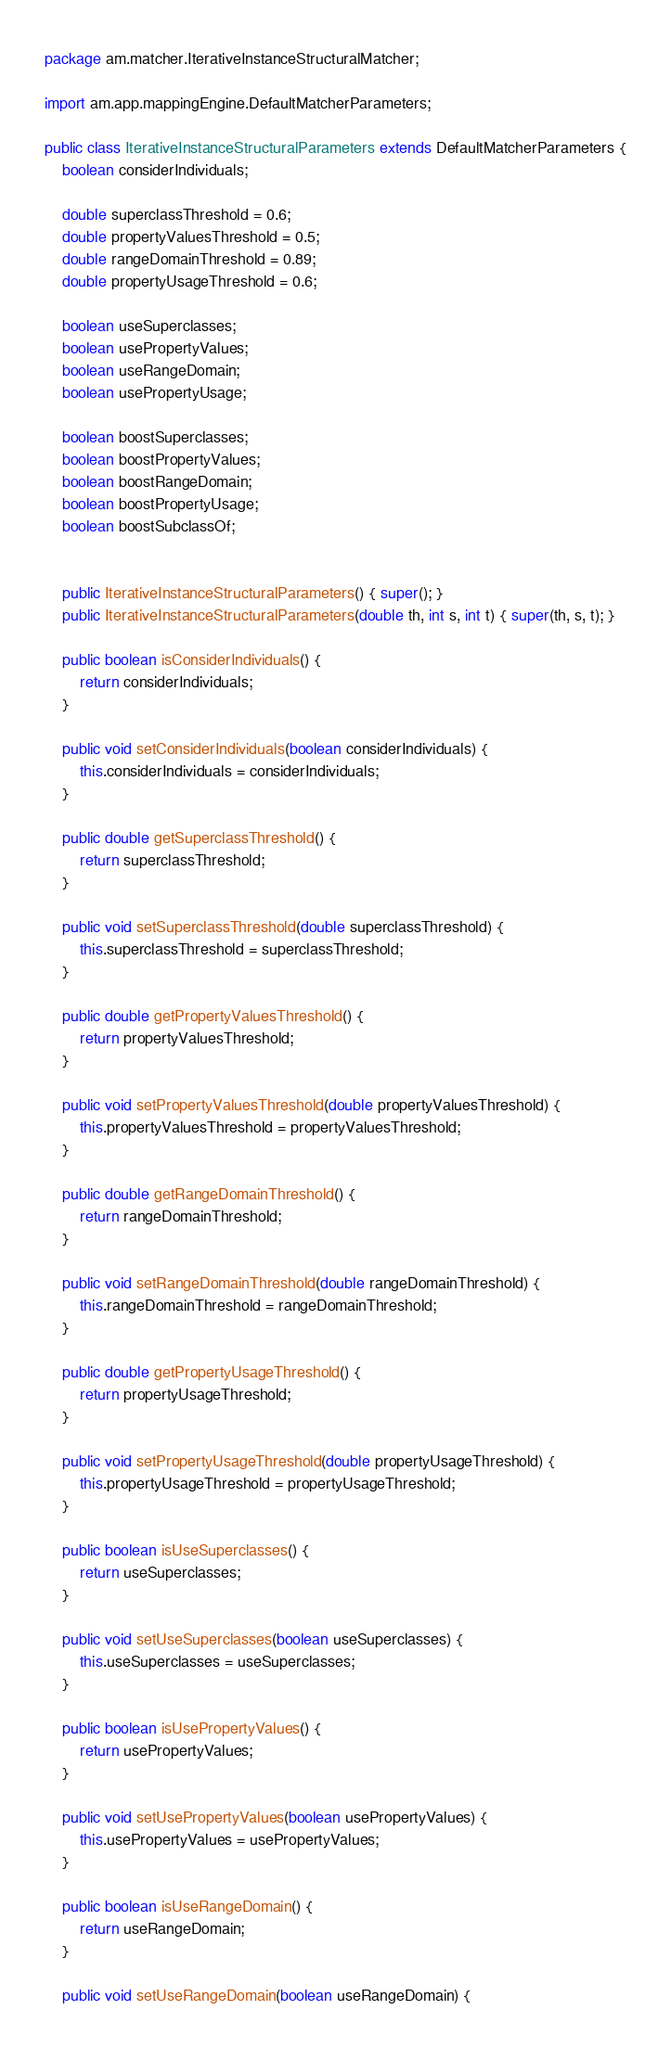Convert code to text. <code><loc_0><loc_0><loc_500><loc_500><_Java_>package am.matcher.IterativeInstanceStructuralMatcher;

import am.app.mappingEngine.DefaultMatcherParameters;

public class IterativeInstanceStructuralParameters extends DefaultMatcherParameters {
	boolean considerIndividuals;
	
	double superclassThreshold = 0.6;
	double propertyValuesThreshold = 0.5;
	double rangeDomainThreshold = 0.89;
	double propertyUsageThreshold = 0.6;
	
	boolean useSuperclasses;
	boolean usePropertyValues;
	boolean useRangeDomain;
	boolean usePropertyUsage;
	
	boolean boostSuperclasses;
	boolean boostPropertyValues;
	boolean boostRangeDomain;
	boolean boostPropertyUsage;
	boolean boostSubclassOf;
	
	
	public IterativeInstanceStructuralParameters() { super(); }
	public IterativeInstanceStructuralParameters(double th, int s, int t) { super(th, s, t); }
	
	public boolean isConsiderIndividuals() {
		return considerIndividuals;
	}
	
	public void setConsiderIndividuals(boolean considerIndividuals) {
		this.considerIndividuals = considerIndividuals;
	}
	
	public double getSuperclassThreshold() {
		return superclassThreshold;
	}
	
	public void setSuperclassThreshold(double superclassThreshold) {
		this.superclassThreshold = superclassThreshold;
	}
	
	public double getPropertyValuesThreshold() {
		return propertyValuesThreshold;
	}
	
	public void setPropertyValuesThreshold(double propertyValuesThreshold) {
		this.propertyValuesThreshold = propertyValuesThreshold;
	}
	
	public double getRangeDomainThreshold() {
		return rangeDomainThreshold;
	}
	
	public void setRangeDomainThreshold(double rangeDomainThreshold) {
		this.rangeDomainThreshold = rangeDomainThreshold;
	}
	
	public double getPropertyUsageThreshold() {
		return propertyUsageThreshold;
	}
	
	public void setPropertyUsageThreshold(double propertyUsageThreshold) {
		this.propertyUsageThreshold = propertyUsageThreshold;
	}

	public boolean isUseSuperclasses() {
		return useSuperclasses;
	}

	public void setUseSuperclasses(boolean useSuperclasses) {
		this.useSuperclasses = useSuperclasses;
	}

	public boolean isUsePropertyValues() {
		return usePropertyValues;
	}

	public void setUsePropertyValues(boolean usePropertyValues) {
		this.usePropertyValues = usePropertyValues;
	}

	public boolean isUseRangeDomain() {
		return useRangeDomain;
	}

	public void setUseRangeDomain(boolean useRangeDomain) {</code> 